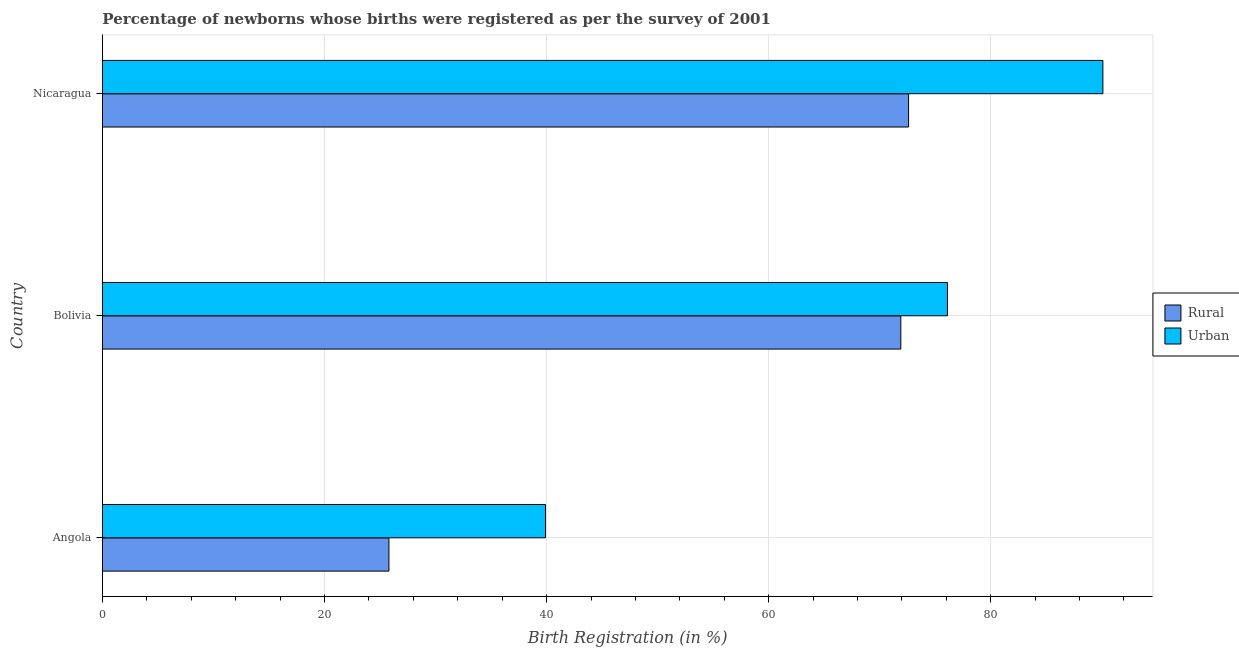Are the number of bars per tick equal to the number of legend labels?
Your answer should be very brief. Yes. How many bars are there on the 2nd tick from the bottom?
Ensure brevity in your answer.  2. What is the label of the 2nd group of bars from the top?
Make the answer very short. Bolivia. In how many cases, is the number of bars for a given country not equal to the number of legend labels?
Provide a succinct answer. 0. What is the urban birth registration in Bolivia?
Your response must be concise. 76.1. Across all countries, what is the maximum rural birth registration?
Offer a terse response. 72.6. Across all countries, what is the minimum urban birth registration?
Your answer should be very brief. 39.9. In which country was the rural birth registration maximum?
Ensure brevity in your answer.  Nicaragua. In which country was the urban birth registration minimum?
Offer a very short reply. Angola. What is the total urban birth registration in the graph?
Offer a terse response. 206.1. What is the difference between the rural birth registration in Angola and that in Bolivia?
Provide a short and direct response. -46.1. What is the difference between the urban birth registration in Angola and the rural birth registration in Nicaragua?
Make the answer very short. -32.7. What is the average rural birth registration per country?
Keep it short and to the point. 56.77. What is the difference between the rural birth registration and urban birth registration in Angola?
Offer a terse response. -14.1. In how many countries, is the rural birth registration greater than 68 %?
Give a very brief answer. 2. What is the ratio of the rural birth registration in Angola to that in Nicaragua?
Make the answer very short. 0.35. Is the urban birth registration in Angola less than that in Nicaragua?
Offer a terse response. Yes. What is the difference between the highest and the lowest urban birth registration?
Provide a succinct answer. 50.2. What does the 1st bar from the top in Bolivia represents?
Keep it short and to the point. Urban. What does the 2nd bar from the bottom in Angola represents?
Make the answer very short. Urban. Are all the bars in the graph horizontal?
Keep it short and to the point. Yes. Does the graph contain grids?
Offer a very short reply. Yes. Where does the legend appear in the graph?
Offer a terse response. Center right. What is the title of the graph?
Offer a very short reply. Percentage of newborns whose births were registered as per the survey of 2001. Does "Register a business" appear as one of the legend labels in the graph?
Offer a very short reply. No. What is the label or title of the X-axis?
Give a very brief answer. Birth Registration (in %). What is the label or title of the Y-axis?
Your answer should be compact. Country. What is the Birth Registration (in %) in Rural in Angola?
Your response must be concise. 25.8. What is the Birth Registration (in %) in Urban in Angola?
Your answer should be very brief. 39.9. What is the Birth Registration (in %) in Rural in Bolivia?
Provide a succinct answer. 71.9. What is the Birth Registration (in %) in Urban in Bolivia?
Your response must be concise. 76.1. What is the Birth Registration (in %) of Rural in Nicaragua?
Make the answer very short. 72.6. What is the Birth Registration (in %) of Urban in Nicaragua?
Your answer should be very brief. 90.1. Across all countries, what is the maximum Birth Registration (in %) in Rural?
Make the answer very short. 72.6. Across all countries, what is the maximum Birth Registration (in %) in Urban?
Your response must be concise. 90.1. Across all countries, what is the minimum Birth Registration (in %) of Rural?
Offer a terse response. 25.8. Across all countries, what is the minimum Birth Registration (in %) of Urban?
Give a very brief answer. 39.9. What is the total Birth Registration (in %) in Rural in the graph?
Ensure brevity in your answer.  170.3. What is the total Birth Registration (in %) in Urban in the graph?
Keep it short and to the point. 206.1. What is the difference between the Birth Registration (in %) of Rural in Angola and that in Bolivia?
Your answer should be compact. -46.1. What is the difference between the Birth Registration (in %) of Urban in Angola and that in Bolivia?
Offer a very short reply. -36.2. What is the difference between the Birth Registration (in %) of Rural in Angola and that in Nicaragua?
Provide a short and direct response. -46.8. What is the difference between the Birth Registration (in %) in Urban in Angola and that in Nicaragua?
Your answer should be very brief. -50.2. What is the difference between the Birth Registration (in %) in Rural in Bolivia and that in Nicaragua?
Offer a very short reply. -0.7. What is the difference between the Birth Registration (in %) of Rural in Angola and the Birth Registration (in %) of Urban in Bolivia?
Provide a short and direct response. -50.3. What is the difference between the Birth Registration (in %) of Rural in Angola and the Birth Registration (in %) of Urban in Nicaragua?
Your answer should be very brief. -64.3. What is the difference between the Birth Registration (in %) of Rural in Bolivia and the Birth Registration (in %) of Urban in Nicaragua?
Give a very brief answer. -18.2. What is the average Birth Registration (in %) in Rural per country?
Your response must be concise. 56.77. What is the average Birth Registration (in %) of Urban per country?
Make the answer very short. 68.7. What is the difference between the Birth Registration (in %) in Rural and Birth Registration (in %) in Urban in Angola?
Ensure brevity in your answer.  -14.1. What is the difference between the Birth Registration (in %) of Rural and Birth Registration (in %) of Urban in Bolivia?
Your answer should be compact. -4.2. What is the difference between the Birth Registration (in %) in Rural and Birth Registration (in %) in Urban in Nicaragua?
Your answer should be very brief. -17.5. What is the ratio of the Birth Registration (in %) of Rural in Angola to that in Bolivia?
Offer a terse response. 0.36. What is the ratio of the Birth Registration (in %) in Urban in Angola to that in Bolivia?
Provide a succinct answer. 0.52. What is the ratio of the Birth Registration (in %) of Rural in Angola to that in Nicaragua?
Make the answer very short. 0.36. What is the ratio of the Birth Registration (in %) of Urban in Angola to that in Nicaragua?
Your answer should be very brief. 0.44. What is the ratio of the Birth Registration (in %) in Urban in Bolivia to that in Nicaragua?
Your answer should be very brief. 0.84. What is the difference between the highest and the second highest Birth Registration (in %) of Rural?
Keep it short and to the point. 0.7. What is the difference between the highest and the second highest Birth Registration (in %) in Urban?
Your answer should be compact. 14. What is the difference between the highest and the lowest Birth Registration (in %) of Rural?
Your answer should be very brief. 46.8. What is the difference between the highest and the lowest Birth Registration (in %) in Urban?
Your answer should be very brief. 50.2. 